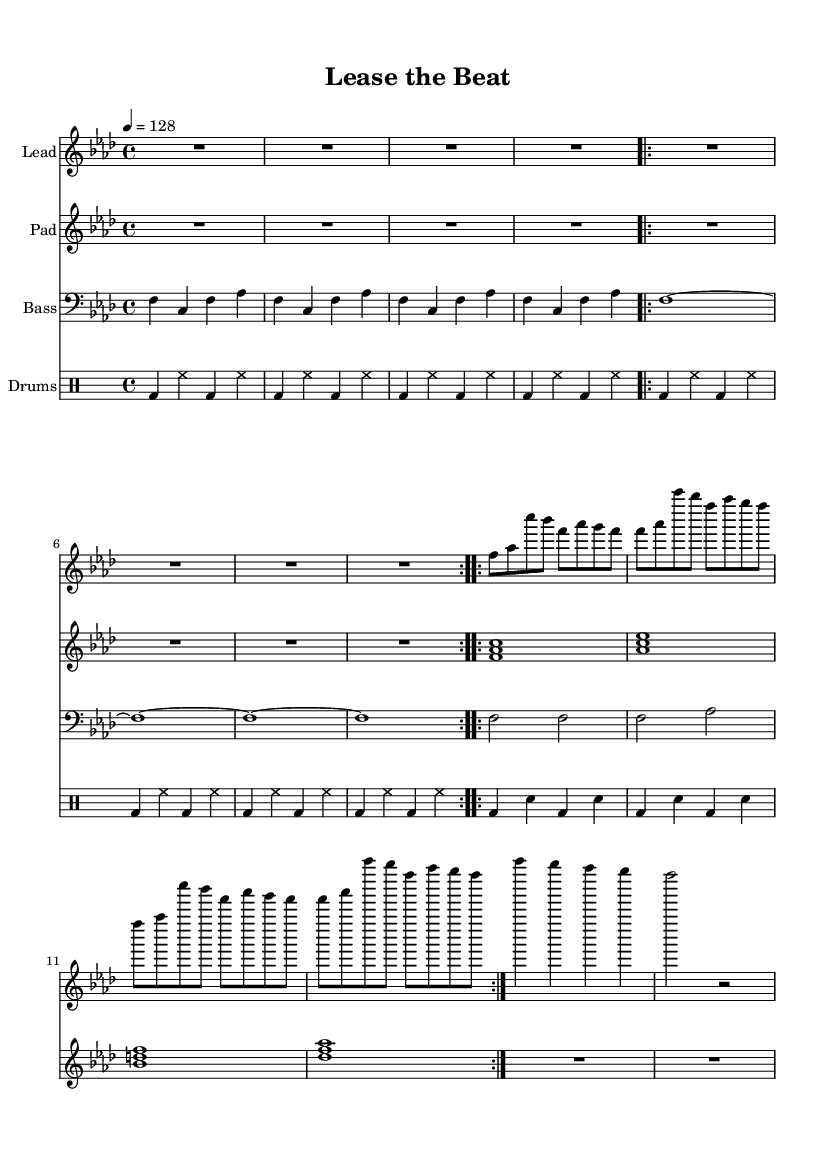What is the key signature of this music? The key signature is F minor, which has four flats indicated. This can be identified by looking at the key signature placed after the clef at the beginning of the score.
Answer: F minor What is the time signature of this music? The time signature is 4/4, which is shown as a fraction at the beginning of the score. This indicates that there are four beats in each measure and that the quarter note gets one beat.
Answer: 4/4 What is the tempo marking specified in this music? The tempo marking is indicated as 4 = 128, which tells us that a quarter note (represented by 4) should be played at a speed of 128 beats per minute. This gives an insight into the pace of the track.
Answer: 128 How many times is the lead synth pattern repeated? The lead synth pattern is repeated twice, which is noted by the "volta 2" instruction that follows the pattern in the score. This means play the section twice before moving on.
Answer: 2 What type of sound does the pad synth produce? The pad synth produces sounds represented by the chords shown in the staff, which typically create a smooth, atmospheric background, common in house music. It plays sustained chords, enhancing the harmonic texture of the track.
Answer: Chords What kind of drum pattern is used in the drums part? The drum part uses a typical house-style pattern consisting of bass drums (bd) and hi-hats (hh) with a steady, consistent beat which maintains the energy and drive essential in house music.
Answer: Steady beat How does the bass synth contribute to the overall feel of the piece? The bass synth plays a repetitive pattern of bass notes that establishes a groove, crucial for maintaining rhythm and energy in house music. This repetitive nature reinforces the danceability of the track.
Answer: Groove 